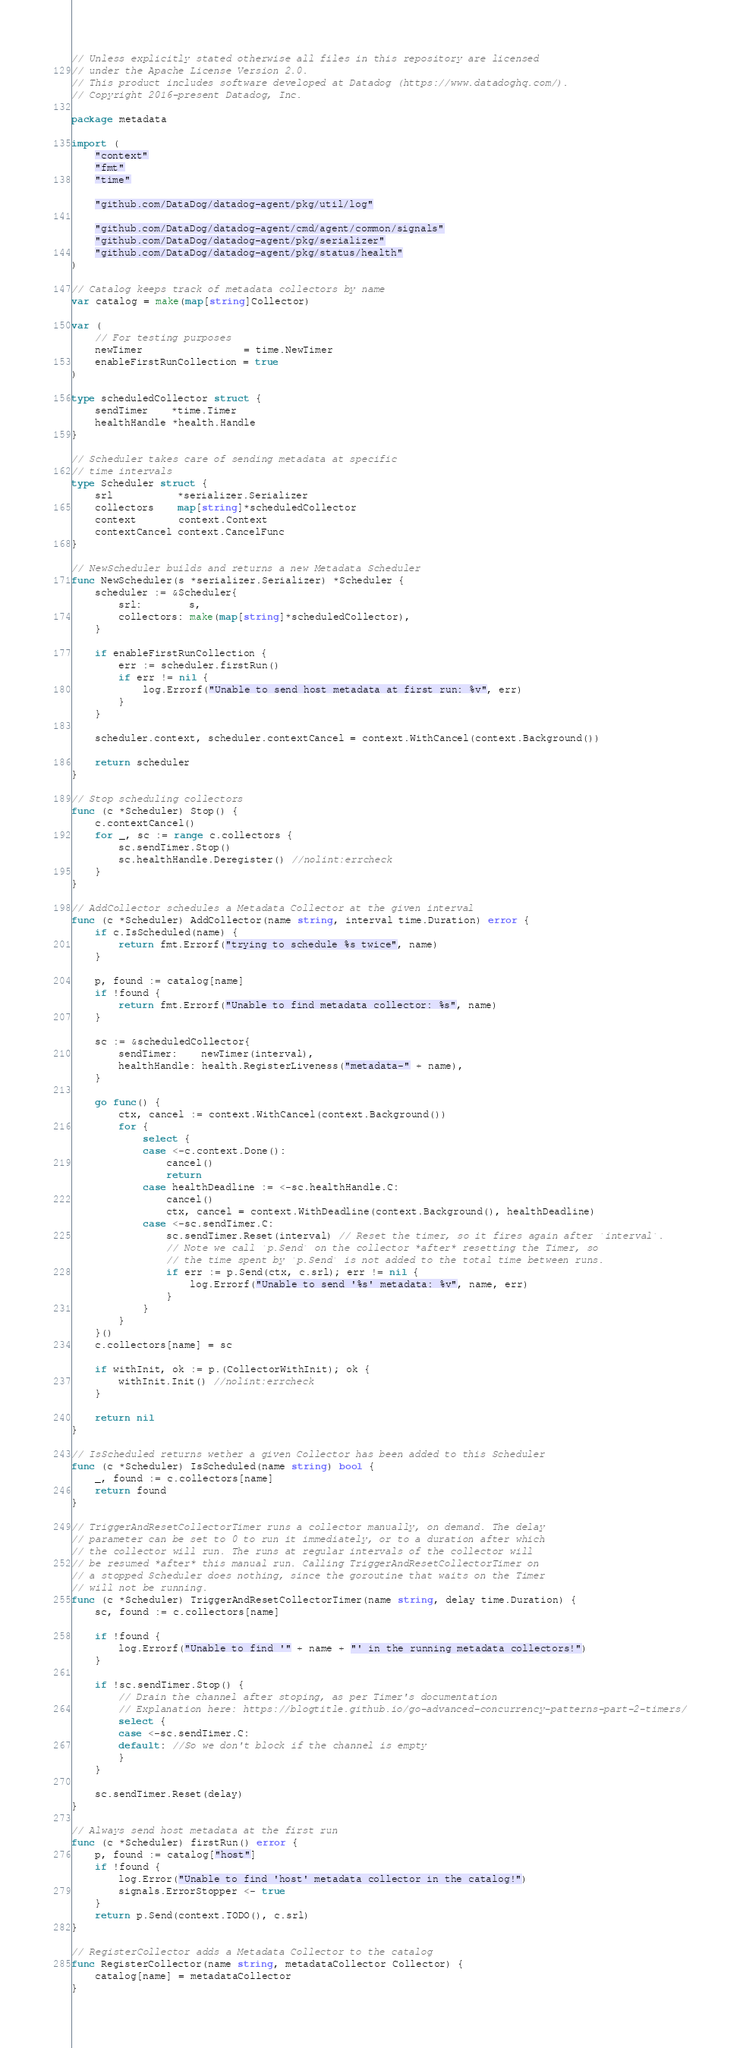Convert code to text. <code><loc_0><loc_0><loc_500><loc_500><_Go_>// Unless explicitly stated otherwise all files in this repository are licensed
// under the Apache License Version 2.0.
// This product includes software developed at Datadog (https://www.datadoghq.com/).
// Copyright 2016-present Datadog, Inc.

package metadata

import (
	"context"
	"fmt"
	"time"

	"github.com/DataDog/datadog-agent/pkg/util/log"

	"github.com/DataDog/datadog-agent/cmd/agent/common/signals"
	"github.com/DataDog/datadog-agent/pkg/serializer"
	"github.com/DataDog/datadog-agent/pkg/status/health"
)

// Catalog keeps track of metadata collectors by name
var catalog = make(map[string]Collector)

var (
	// For testing purposes
	newTimer                 = time.NewTimer
	enableFirstRunCollection = true
)

type scheduledCollector struct {
	sendTimer    *time.Timer
	healthHandle *health.Handle
}

// Scheduler takes care of sending metadata at specific
// time intervals
type Scheduler struct {
	srl           *serializer.Serializer
	collectors    map[string]*scheduledCollector
	context       context.Context
	contextCancel context.CancelFunc
}

// NewScheduler builds and returns a new Metadata Scheduler
func NewScheduler(s *serializer.Serializer) *Scheduler {
	scheduler := &Scheduler{
		srl:        s,
		collectors: make(map[string]*scheduledCollector),
	}

	if enableFirstRunCollection {
		err := scheduler.firstRun()
		if err != nil {
			log.Errorf("Unable to send host metadata at first run: %v", err)
		}
	}

	scheduler.context, scheduler.contextCancel = context.WithCancel(context.Background())

	return scheduler
}

// Stop scheduling collectors
func (c *Scheduler) Stop() {
	c.contextCancel()
	for _, sc := range c.collectors {
		sc.sendTimer.Stop()
		sc.healthHandle.Deregister() //nolint:errcheck
	}
}

// AddCollector schedules a Metadata Collector at the given interval
func (c *Scheduler) AddCollector(name string, interval time.Duration) error {
	if c.IsScheduled(name) {
		return fmt.Errorf("trying to schedule %s twice", name)
	}

	p, found := catalog[name]
	if !found {
		return fmt.Errorf("Unable to find metadata collector: %s", name)
	}

	sc := &scheduledCollector{
		sendTimer:    newTimer(interval),
		healthHandle: health.RegisterLiveness("metadata-" + name),
	}

	go func() {
		ctx, cancel := context.WithCancel(context.Background())
		for {
			select {
			case <-c.context.Done():
				cancel()
				return
			case healthDeadline := <-sc.healthHandle.C:
				cancel()
				ctx, cancel = context.WithDeadline(context.Background(), healthDeadline)
			case <-sc.sendTimer.C:
				sc.sendTimer.Reset(interval) // Reset the timer, so it fires again after `interval`.
				// Note we call `p.Send` on the collector *after* resetting the Timer, so
				// the time spent by `p.Send` is not added to the total time between runs.
				if err := p.Send(ctx, c.srl); err != nil {
					log.Errorf("Unable to send '%s' metadata: %v", name, err)
				}
			}
		}
	}()
	c.collectors[name] = sc

	if withInit, ok := p.(CollectorWithInit); ok {
		withInit.Init() //nolint:errcheck
	}

	return nil
}

// IsScheduled returns wether a given Collector has been added to this Scheduler
func (c *Scheduler) IsScheduled(name string) bool {
	_, found := c.collectors[name]
	return found
}

// TriggerAndResetCollectorTimer runs a collector manually, on demand. The delay
// parameter can be set to 0 to run it immediately, or to a duration after which
// the collector will run. The runs at regular intervals of the collector will
// be resumed *after* this manual run. Calling TriggerAndResetCollectorTimer on
// a stopped Scheduler does nothing, since the goroutine that waits on the Timer
// will not be running.
func (c *Scheduler) TriggerAndResetCollectorTimer(name string, delay time.Duration) {
	sc, found := c.collectors[name]

	if !found {
		log.Errorf("Unable to find '" + name + "' in the running metadata collectors!")
	}

	if !sc.sendTimer.Stop() {
		// Drain the channel after stoping, as per Timer's documentation
		// Explanation here: https://blogtitle.github.io/go-advanced-concurrency-patterns-part-2-timers/
		select {
		case <-sc.sendTimer.C:
		default: //So we don't block if the channel is empty
		}
	}

	sc.sendTimer.Reset(delay)
}

// Always send host metadata at the first run
func (c *Scheduler) firstRun() error {
	p, found := catalog["host"]
	if !found {
		log.Error("Unable to find 'host' metadata collector in the catalog!")
		signals.ErrorStopper <- true
	}
	return p.Send(context.TODO(), c.srl)
}

// RegisterCollector adds a Metadata Collector to the catalog
func RegisterCollector(name string, metadataCollector Collector) {
	catalog[name] = metadataCollector
}
</code> 